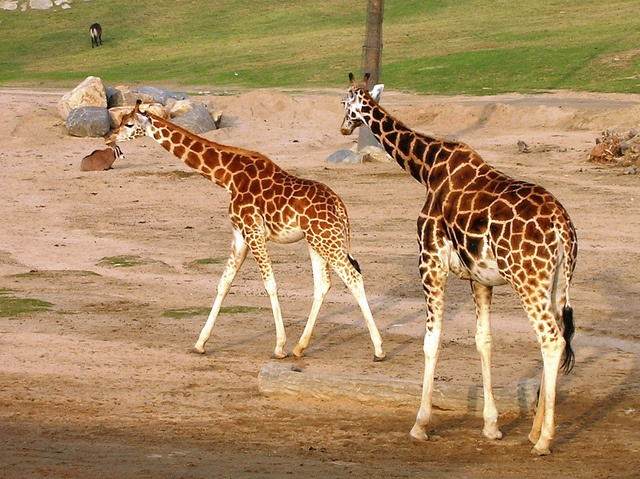Describe the objects in this image and their specific colors. I can see giraffe in gray, maroon, tan, and brown tones and giraffe in gray, maroon, beige, brown, and tan tones in this image. 